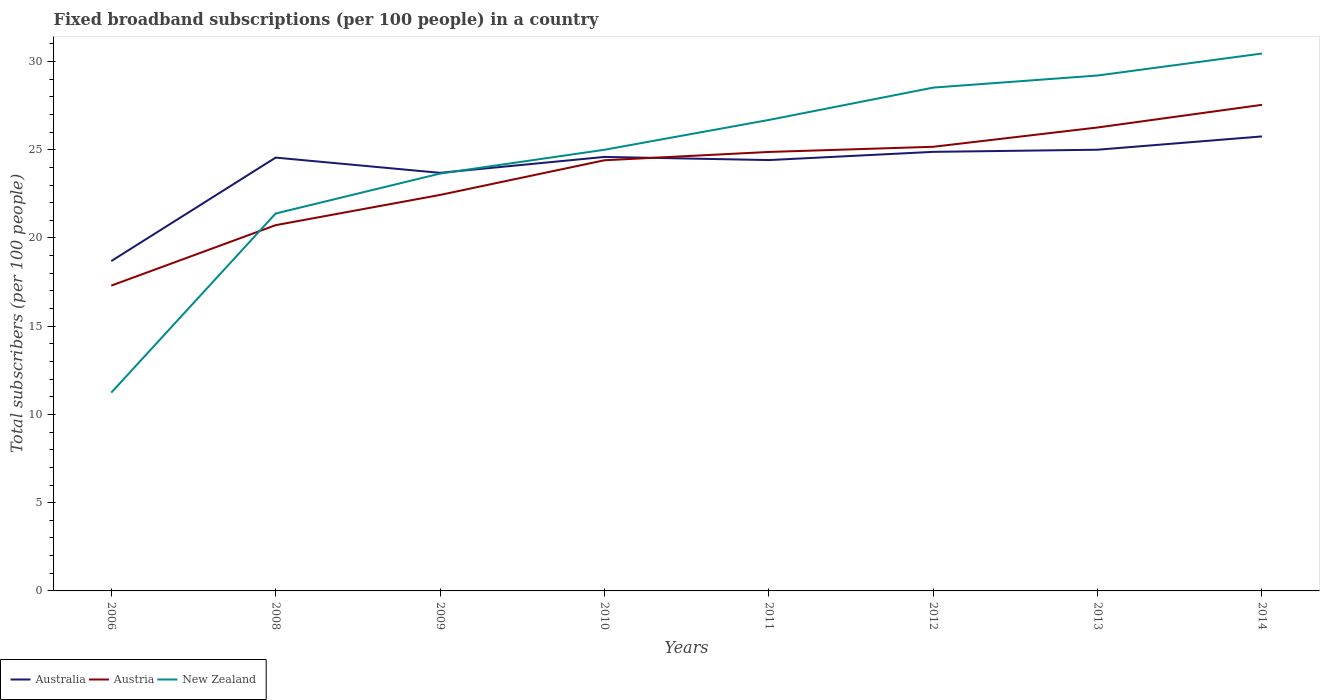How many different coloured lines are there?
Your answer should be compact. 3. Across all years, what is the maximum number of broadband subscriptions in New Zealand?
Provide a short and direct response. 11.24. In which year was the number of broadband subscriptions in Australia maximum?
Your answer should be compact. 2006. What is the total number of broadband subscriptions in Australia in the graph?
Offer a very short reply. -0.04. What is the difference between the highest and the second highest number of broadband subscriptions in New Zealand?
Offer a very short reply. 19.22. What is the difference between the highest and the lowest number of broadband subscriptions in Australia?
Give a very brief answer. 6. Are the values on the major ticks of Y-axis written in scientific E-notation?
Offer a very short reply. No. Does the graph contain any zero values?
Make the answer very short. No. Does the graph contain grids?
Keep it short and to the point. No. Where does the legend appear in the graph?
Ensure brevity in your answer.  Bottom left. How many legend labels are there?
Provide a succinct answer. 3. What is the title of the graph?
Offer a very short reply. Fixed broadband subscriptions (per 100 people) in a country. Does "Aruba" appear as one of the legend labels in the graph?
Ensure brevity in your answer.  No. What is the label or title of the Y-axis?
Give a very brief answer. Total subscribers (per 100 people). What is the Total subscribers (per 100 people) of Australia in 2006?
Provide a succinct answer. 18.69. What is the Total subscribers (per 100 people) of Austria in 2006?
Your answer should be compact. 17.3. What is the Total subscribers (per 100 people) in New Zealand in 2006?
Give a very brief answer. 11.24. What is the Total subscribers (per 100 people) of Australia in 2008?
Your answer should be very brief. 24.56. What is the Total subscribers (per 100 people) of Austria in 2008?
Offer a very short reply. 20.73. What is the Total subscribers (per 100 people) of New Zealand in 2008?
Provide a succinct answer. 21.39. What is the Total subscribers (per 100 people) of Australia in 2009?
Keep it short and to the point. 23.69. What is the Total subscribers (per 100 people) in Austria in 2009?
Your response must be concise. 22.44. What is the Total subscribers (per 100 people) of New Zealand in 2009?
Provide a succinct answer. 23.65. What is the Total subscribers (per 100 people) in Australia in 2010?
Keep it short and to the point. 24.59. What is the Total subscribers (per 100 people) of Austria in 2010?
Make the answer very short. 24.4. What is the Total subscribers (per 100 people) in New Zealand in 2010?
Your answer should be compact. 25. What is the Total subscribers (per 100 people) of Australia in 2011?
Your response must be concise. 24.41. What is the Total subscribers (per 100 people) of Austria in 2011?
Your answer should be very brief. 24.88. What is the Total subscribers (per 100 people) of New Zealand in 2011?
Offer a very short reply. 26.69. What is the Total subscribers (per 100 people) in Australia in 2012?
Offer a very short reply. 24.88. What is the Total subscribers (per 100 people) in Austria in 2012?
Keep it short and to the point. 25.17. What is the Total subscribers (per 100 people) in New Zealand in 2012?
Your response must be concise. 28.52. What is the Total subscribers (per 100 people) in Australia in 2013?
Ensure brevity in your answer.  25. What is the Total subscribers (per 100 people) in Austria in 2013?
Your answer should be compact. 26.26. What is the Total subscribers (per 100 people) of New Zealand in 2013?
Keep it short and to the point. 29.21. What is the Total subscribers (per 100 people) of Australia in 2014?
Ensure brevity in your answer.  25.76. What is the Total subscribers (per 100 people) of Austria in 2014?
Give a very brief answer. 27.54. What is the Total subscribers (per 100 people) in New Zealand in 2014?
Your answer should be compact. 30.45. Across all years, what is the maximum Total subscribers (per 100 people) of Australia?
Ensure brevity in your answer.  25.76. Across all years, what is the maximum Total subscribers (per 100 people) of Austria?
Your response must be concise. 27.54. Across all years, what is the maximum Total subscribers (per 100 people) in New Zealand?
Provide a short and direct response. 30.45. Across all years, what is the minimum Total subscribers (per 100 people) in Australia?
Ensure brevity in your answer.  18.69. Across all years, what is the minimum Total subscribers (per 100 people) of Austria?
Keep it short and to the point. 17.3. Across all years, what is the minimum Total subscribers (per 100 people) in New Zealand?
Provide a succinct answer. 11.24. What is the total Total subscribers (per 100 people) of Australia in the graph?
Offer a very short reply. 191.58. What is the total Total subscribers (per 100 people) in Austria in the graph?
Your response must be concise. 188.72. What is the total Total subscribers (per 100 people) of New Zealand in the graph?
Your answer should be very brief. 196.14. What is the difference between the Total subscribers (per 100 people) of Australia in 2006 and that in 2008?
Provide a short and direct response. -5.86. What is the difference between the Total subscribers (per 100 people) of Austria in 2006 and that in 2008?
Ensure brevity in your answer.  -3.43. What is the difference between the Total subscribers (per 100 people) in New Zealand in 2006 and that in 2008?
Offer a terse response. -10.15. What is the difference between the Total subscribers (per 100 people) of Australia in 2006 and that in 2009?
Give a very brief answer. -5. What is the difference between the Total subscribers (per 100 people) in Austria in 2006 and that in 2009?
Your response must be concise. -5.14. What is the difference between the Total subscribers (per 100 people) in New Zealand in 2006 and that in 2009?
Your answer should be compact. -12.41. What is the difference between the Total subscribers (per 100 people) in Australia in 2006 and that in 2010?
Provide a succinct answer. -5.9. What is the difference between the Total subscribers (per 100 people) in Austria in 2006 and that in 2010?
Give a very brief answer. -7.1. What is the difference between the Total subscribers (per 100 people) in New Zealand in 2006 and that in 2010?
Ensure brevity in your answer.  -13.76. What is the difference between the Total subscribers (per 100 people) of Australia in 2006 and that in 2011?
Your response must be concise. -5.72. What is the difference between the Total subscribers (per 100 people) of Austria in 2006 and that in 2011?
Provide a succinct answer. -7.58. What is the difference between the Total subscribers (per 100 people) of New Zealand in 2006 and that in 2011?
Offer a terse response. -15.45. What is the difference between the Total subscribers (per 100 people) of Australia in 2006 and that in 2012?
Keep it short and to the point. -6.19. What is the difference between the Total subscribers (per 100 people) in Austria in 2006 and that in 2012?
Give a very brief answer. -7.87. What is the difference between the Total subscribers (per 100 people) in New Zealand in 2006 and that in 2012?
Offer a terse response. -17.29. What is the difference between the Total subscribers (per 100 people) of Australia in 2006 and that in 2013?
Offer a very short reply. -6.31. What is the difference between the Total subscribers (per 100 people) of Austria in 2006 and that in 2013?
Ensure brevity in your answer.  -8.96. What is the difference between the Total subscribers (per 100 people) of New Zealand in 2006 and that in 2013?
Offer a terse response. -17.97. What is the difference between the Total subscribers (per 100 people) of Australia in 2006 and that in 2014?
Give a very brief answer. -7.06. What is the difference between the Total subscribers (per 100 people) of Austria in 2006 and that in 2014?
Provide a succinct answer. -10.24. What is the difference between the Total subscribers (per 100 people) of New Zealand in 2006 and that in 2014?
Your answer should be very brief. -19.22. What is the difference between the Total subscribers (per 100 people) of Australia in 2008 and that in 2009?
Provide a succinct answer. 0.86. What is the difference between the Total subscribers (per 100 people) of Austria in 2008 and that in 2009?
Provide a short and direct response. -1.71. What is the difference between the Total subscribers (per 100 people) of New Zealand in 2008 and that in 2009?
Ensure brevity in your answer.  -2.26. What is the difference between the Total subscribers (per 100 people) of Australia in 2008 and that in 2010?
Your response must be concise. -0.04. What is the difference between the Total subscribers (per 100 people) in Austria in 2008 and that in 2010?
Your answer should be compact. -3.68. What is the difference between the Total subscribers (per 100 people) of New Zealand in 2008 and that in 2010?
Your answer should be very brief. -3.61. What is the difference between the Total subscribers (per 100 people) of Australia in 2008 and that in 2011?
Your answer should be compact. 0.14. What is the difference between the Total subscribers (per 100 people) of Austria in 2008 and that in 2011?
Provide a short and direct response. -4.15. What is the difference between the Total subscribers (per 100 people) in New Zealand in 2008 and that in 2011?
Ensure brevity in your answer.  -5.3. What is the difference between the Total subscribers (per 100 people) of Australia in 2008 and that in 2012?
Your answer should be compact. -0.33. What is the difference between the Total subscribers (per 100 people) in Austria in 2008 and that in 2012?
Offer a terse response. -4.44. What is the difference between the Total subscribers (per 100 people) of New Zealand in 2008 and that in 2012?
Ensure brevity in your answer.  -7.13. What is the difference between the Total subscribers (per 100 people) of Australia in 2008 and that in 2013?
Give a very brief answer. -0.45. What is the difference between the Total subscribers (per 100 people) in Austria in 2008 and that in 2013?
Provide a short and direct response. -5.54. What is the difference between the Total subscribers (per 100 people) in New Zealand in 2008 and that in 2013?
Make the answer very short. -7.82. What is the difference between the Total subscribers (per 100 people) of Austria in 2008 and that in 2014?
Your answer should be very brief. -6.82. What is the difference between the Total subscribers (per 100 people) in New Zealand in 2008 and that in 2014?
Keep it short and to the point. -9.07. What is the difference between the Total subscribers (per 100 people) in Australia in 2009 and that in 2010?
Your answer should be compact. -0.9. What is the difference between the Total subscribers (per 100 people) in Austria in 2009 and that in 2010?
Your answer should be compact. -1.97. What is the difference between the Total subscribers (per 100 people) in New Zealand in 2009 and that in 2010?
Provide a short and direct response. -1.35. What is the difference between the Total subscribers (per 100 people) in Australia in 2009 and that in 2011?
Give a very brief answer. -0.72. What is the difference between the Total subscribers (per 100 people) of Austria in 2009 and that in 2011?
Keep it short and to the point. -2.44. What is the difference between the Total subscribers (per 100 people) of New Zealand in 2009 and that in 2011?
Your answer should be very brief. -3.04. What is the difference between the Total subscribers (per 100 people) in Australia in 2009 and that in 2012?
Keep it short and to the point. -1.19. What is the difference between the Total subscribers (per 100 people) of Austria in 2009 and that in 2012?
Ensure brevity in your answer.  -2.73. What is the difference between the Total subscribers (per 100 people) in New Zealand in 2009 and that in 2012?
Ensure brevity in your answer.  -4.87. What is the difference between the Total subscribers (per 100 people) in Australia in 2009 and that in 2013?
Make the answer very short. -1.31. What is the difference between the Total subscribers (per 100 people) of Austria in 2009 and that in 2013?
Make the answer very short. -3.82. What is the difference between the Total subscribers (per 100 people) of New Zealand in 2009 and that in 2013?
Your answer should be very brief. -5.56. What is the difference between the Total subscribers (per 100 people) in Australia in 2009 and that in 2014?
Your answer should be very brief. -2.06. What is the difference between the Total subscribers (per 100 people) of Austria in 2009 and that in 2014?
Your response must be concise. -5.11. What is the difference between the Total subscribers (per 100 people) of New Zealand in 2009 and that in 2014?
Provide a short and direct response. -6.8. What is the difference between the Total subscribers (per 100 people) of Australia in 2010 and that in 2011?
Provide a short and direct response. 0.18. What is the difference between the Total subscribers (per 100 people) of Austria in 2010 and that in 2011?
Provide a short and direct response. -0.47. What is the difference between the Total subscribers (per 100 people) in New Zealand in 2010 and that in 2011?
Give a very brief answer. -1.69. What is the difference between the Total subscribers (per 100 people) in Australia in 2010 and that in 2012?
Give a very brief answer. -0.29. What is the difference between the Total subscribers (per 100 people) in Austria in 2010 and that in 2012?
Ensure brevity in your answer.  -0.76. What is the difference between the Total subscribers (per 100 people) of New Zealand in 2010 and that in 2012?
Ensure brevity in your answer.  -3.52. What is the difference between the Total subscribers (per 100 people) in Australia in 2010 and that in 2013?
Keep it short and to the point. -0.41. What is the difference between the Total subscribers (per 100 people) in Austria in 2010 and that in 2013?
Your answer should be very brief. -1.86. What is the difference between the Total subscribers (per 100 people) in New Zealand in 2010 and that in 2013?
Ensure brevity in your answer.  -4.21. What is the difference between the Total subscribers (per 100 people) of Australia in 2010 and that in 2014?
Keep it short and to the point. -1.16. What is the difference between the Total subscribers (per 100 people) of Austria in 2010 and that in 2014?
Your answer should be compact. -3.14. What is the difference between the Total subscribers (per 100 people) in New Zealand in 2010 and that in 2014?
Offer a very short reply. -5.45. What is the difference between the Total subscribers (per 100 people) of Australia in 2011 and that in 2012?
Ensure brevity in your answer.  -0.47. What is the difference between the Total subscribers (per 100 people) of Austria in 2011 and that in 2012?
Make the answer very short. -0.29. What is the difference between the Total subscribers (per 100 people) in New Zealand in 2011 and that in 2012?
Your response must be concise. -1.83. What is the difference between the Total subscribers (per 100 people) in Australia in 2011 and that in 2013?
Your answer should be compact. -0.59. What is the difference between the Total subscribers (per 100 people) of Austria in 2011 and that in 2013?
Keep it short and to the point. -1.39. What is the difference between the Total subscribers (per 100 people) of New Zealand in 2011 and that in 2013?
Make the answer very short. -2.52. What is the difference between the Total subscribers (per 100 people) in Australia in 2011 and that in 2014?
Make the answer very short. -1.34. What is the difference between the Total subscribers (per 100 people) of Austria in 2011 and that in 2014?
Give a very brief answer. -2.67. What is the difference between the Total subscribers (per 100 people) of New Zealand in 2011 and that in 2014?
Your answer should be very brief. -3.76. What is the difference between the Total subscribers (per 100 people) in Australia in 2012 and that in 2013?
Give a very brief answer. -0.12. What is the difference between the Total subscribers (per 100 people) of Austria in 2012 and that in 2013?
Ensure brevity in your answer.  -1.09. What is the difference between the Total subscribers (per 100 people) of New Zealand in 2012 and that in 2013?
Offer a very short reply. -0.69. What is the difference between the Total subscribers (per 100 people) of Australia in 2012 and that in 2014?
Your answer should be compact. -0.88. What is the difference between the Total subscribers (per 100 people) of Austria in 2012 and that in 2014?
Make the answer very short. -2.38. What is the difference between the Total subscribers (per 100 people) in New Zealand in 2012 and that in 2014?
Offer a terse response. -1.93. What is the difference between the Total subscribers (per 100 people) in Australia in 2013 and that in 2014?
Offer a terse response. -0.75. What is the difference between the Total subscribers (per 100 people) in Austria in 2013 and that in 2014?
Make the answer very short. -1.28. What is the difference between the Total subscribers (per 100 people) in New Zealand in 2013 and that in 2014?
Give a very brief answer. -1.25. What is the difference between the Total subscribers (per 100 people) in Australia in 2006 and the Total subscribers (per 100 people) in Austria in 2008?
Ensure brevity in your answer.  -2.04. What is the difference between the Total subscribers (per 100 people) in Australia in 2006 and the Total subscribers (per 100 people) in New Zealand in 2008?
Ensure brevity in your answer.  -2.7. What is the difference between the Total subscribers (per 100 people) in Austria in 2006 and the Total subscribers (per 100 people) in New Zealand in 2008?
Your answer should be very brief. -4.09. What is the difference between the Total subscribers (per 100 people) of Australia in 2006 and the Total subscribers (per 100 people) of Austria in 2009?
Your response must be concise. -3.75. What is the difference between the Total subscribers (per 100 people) of Australia in 2006 and the Total subscribers (per 100 people) of New Zealand in 2009?
Ensure brevity in your answer.  -4.96. What is the difference between the Total subscribers (per 100 people) in Austria in 2006 and the Total subscribers (per 100 people) in New Zealand in 2009?
Keep it short and to the point. -6.35. What is the difference between the Total subscribers (per 100 people) in Australia in 2006 and the Total subscribers (per 100 people) in Austria in 2010?
Offer a very short reply. -5.71. What is the difference between the Total subscribers (per 100 people) of Australia in 2006 and the Total subscribers (per 100 people) of New Zealand in 2010?
Offer a very short reply. -6.31. What is the difference between the Total subscribers (per 100 people) in Austria in 2006 and the Total subscribers (per 100 people) in New Zealand in 2010?
Offer a terse response. -7.7. What is the difference between the Total subscribers (per 100 people) of Australia in 2006 and the Total subscribers (per 100 people) of Austria in 2011?
Keep it short and to the point. -6.18. What is the difference between the Total subscribers (per 100 people) of Australia in 2006 and the Total subscribers (per 100 people) of New Zealand in 2011?
Your answer should be compact. -8. What is the difference between the Total subscribers (per 100 people) in Austria in 2006 and the Total subscribers (per 100 people) in New Zealand in 2011?
Keep it short and to the point. -9.39. What is the difference between the Total subscribers (per 100 people) in Australia in 2006 and the Total subscribers (per 100 people) in Austria in 2012?
Keep it short and to the point. -6.48. What is the difference between the Total subscribers (per 100 people) in Australia in 2006 and the Total subscribers (per 100 people) in New Zealand in 2012?
Your answer should be compact. -9.83. What is the difference between the Total subscribers (per 100 people) in Austria in 2006 and the Total subscribers (per 100 people) in New Zealand in 2012?
Your answer should be very brief. -11.22. What is the difference between the Total subscribers (per 100 people) of Australia in 2006 and the Total subscribers (per 100 people) of Austria in 2013?
Make the answer very short. -7.57. What is the difference between the Total subscribers (per 100 people) of Australia in 2006 and the Total subscribers (per 100 people) of New Zealand in 2013?
Provide a short and direct response. -10.52. What is the difference between the Total subscribers (per 100 people) in Austria in 2006 and the Total subscribers (per 100 people) in New Zealand in 2013?
Keep it short and to the point. -11.91. What is the difference between the Total subscribers (per 100 people) of Australia in 2006 and the Total subscribers (per 100 people) of Austria in 2014?
Your answer should be very brief. -8.85. What is the difference between the Total subscribers (per 100 people) of Australia in 2006 and the Total subscribers (per 100 people) of New Zealand in 2014?
Your answer should be compact. -11.76. What is the difference between the Total subscribers (per 100 people) in Austria in 2006 and the Total subscribers (per 100 people) in New Zealand in 2014?
Offer a terse response. -13.15. What is the difference between the Total subscribers (per 100 people) of Australia in 2008 and the Total subscribers (per 100 people) of Austria in 2009?
Your answer should be compact. 2.12. What is the difference between the Total subscribers (per 100 people) in Australia in 2008 and the Total subscribers (per 100 people) in New Zealand in 2009?
Offer a very short reply. 0.91. What is the difference between the Total subscribers (per 100 people) of Austria in 2008 and the Total subscribers (per 100 people) of New Zealand in 2009?
Give a very brief answer. -2.92. What is the difference between the Total subscribers (per 100 people) in Australia in 2008 and the Total subscribers (per 100 people) in Austria in 2010?
Your response must be concise. 0.15. What is the difference between the Total subscribers (per 100 people) in Australia in 2008 and the Total subscribers (per 100 people) in New Zealand in 2010?
Offer a very short reply. -0.44. What is the difference between the Total subscribers (per 100 people) of Austria in 2008 and the Total subscribers (per 100 people) of New Zealand in 2010?
Provide a short and direct response. -4.27. What is the difference between the Total subscribers (per 100 people) of Australia in 2008 and the Total subscribers (per 100 people) of Austria in 2011?
Your answer should be very brief. -0.32. What is the difference between the Total subscribers (per 100 people) of Australia in 2008 and the Total subscribers (per 100 people) of New Zealand in 2011?
Give a very brief answer. -2.13. What is the difference between the Total subscribers (per 100 people) in Austria in 2008 and the Total subscribers (per 100 people) in New Zealand in 2011?
Offer a terse response. -5.96. What is the difference between the Total subscribers (per 100 people) in Australia in 2008 and the Total subscribers (per 100 people) in Austria in 2012?
Provide a succinct answer. -0.61. What is the difference between the Total subscribers (per 100 people) in Australia in 2008 and the Total subscribers (per 100 people) in New Zealand in 2012?
Provide a succinct answer. -3.97. What is the difference between the Total subscribers (per 100 people) in Austria in 2008 and the Total subscribers (per 100 people) in New Zealand in 2012?
Make the answer very short. -7.79. What is the difference between the Total subscribers (per 100 people) of Australia in 2008 and the Total subscribers (per 100 people) of Austria in 2013?
Your response must be concise. -1.71. What is the difference between the Total subscribers (per 100 people) in Australia in 2008 and the Total subscribers (per 100 people) in New Zealand in 2013?
Offer a very short reply. -4.65. What is the difference between the Total subscribers (per 100 people) in Austria in 2008 and the Total subscribers (per 100 people) in New Zealand in 2013?
Offer a very short reply. -8.48. What is the difference between the Total subscribers (per 100 people) in Australia in 2008 and the Total subscribers (per 100 people) in Austria in 2014?
Your answer should be compact. -2.99. What is the difference between the Total subscribers (per 100 people) of Australia in 2008 and the Total subscribers (per 100 people) of New Zealand in 2014?
Ensure brevity in your answer.  -5.9. What is the difference between the Total subscribers (per 100 people) of Austria in 2008 and the Total subscribers (per 100 people) of New Zealand in 2014?
Your response must be concise. -9.73. What is the difference between the Total subscribers (per 100 people) in Australia in 2009 and the Total subscribers (per 100 people) in Austria in 2010?
Give a very brief answer. -0.71. What is the difference between the Total subscribers (per 100 people) of Australia in 2009 and the Total subscribers (per 100 people) of New Zealand in 2010?
Keep it short and to the point. -1.31. What is the difference between the Total subscribers (per 100 people) of Austria in 2009 and the Total subscribers (per 100 people) of New Zealand in 2010?
Provide a succinct answer. -2.56. What is the difference between the Total subscribers (per 100 people) of Australia in 2009 and the Total subscribers (per 100 people) of Austria in 2011?
Your answer should be very brief. -1.18. What is the difference between the Total subscribers (per 100 people) of Australia in 2009 and the Total subscribers (per 100 people) of New Zealand in 2011?
Give a very brief answer. -3. What is the difference between the Total subscribers (per 100 people) in Austria in 2009 and the Total subscribers (per 100 people) in New Zealand in 2011?
Ensure brevity in your answer.  -4.25. What is the difference between the Total subscribers (per 100 people) in Australia in 2009 and the Total subscribers (per 100 people) in Austria in 2012?
Keep it short and to the point. -1.48. What is the difference between the Total subscribers (per 100 people) of Australia in 2009 and the Total subscribers (per 100 people) of New Zealand in 2012?
Make the answer very short. -4.83. What is the difference between the Total subscribers (per 100 people) of Austria in 2009 and the Total subscribers (per 100 people) of New Zealand in 2012?
Offer a terse response. -6.08. What is the difference between the Total subscribers (per 100 people) of Australia in 2009 and the Total subscribers (per 100 people) of Austria in 2013?
Provide a short and direct response. -2.57. What is the difference between the Total subscribers (per 100 people) of Australia in 2009 and the Total subscribers (per 100 people) of New Zealand in 2013?
Give a very brief answer. -5.52. What is the difference between the Total subscribers (per 100 people) in Austria in 2009 and the Total subscribers (per 100 people) in New Zealand in 2013?
Your response must be concise. -6.77. What is the difference between the Total subscribers (per 100 people) in Australia in 2009 and the Total subscribers (per 100 people) in Austria in 2014?
Offer a very short reply. -3.85. What is the difference between the Total subscribers (per 100 people) in Australia in 2009 and the Total subscribers (per 100 people) in New Zealand in 2014?
Offer a terse response. -6.76. What is the difference between the Total subscribers (per 100 people) in Austria in 2009 and the Total subscribers (per 100 people) in New Zealand in 2014?
Provide a succinct answer. -8.01. What is the difference between the Total subscribers (per 100 people) of Australia in 2010 and the Total subscribers (per 100 people) of Austria in 2011?
Make the answer very short. -0.28. What is the difference between the Total subscribers (per 100 people) of Australia in 2010 and the Total subscribers (per 100 people) of New Zealand in 2011?
Make the answer very short. -2.1. What is the difference between the Total subscribers (per 100 people) of Austria in 2010 and the Total subscribers (per 100 people) of New Zealand in 2011?
Keep it short and to the point. -2.28. What is the difference between the Total subscribers (per 100 people) of Australia in 2010 and the Total subscribers (per 100 people) of Austria in 2012?
Offer a terse response. -0.57. What is the difference between the Total subscribers (per 100 people) in Australia in 2010 and the Total subscribers (per 100 people) in New Zealand in 2012?
Provide a short and direct response. -3.93. What is the difference between the Total subscribers (per 100 people) of Austria in 2010 and the Total subscribers (per 100 people) of New Zealand in 2012?
Provide a succinct answer. -4.12. What is the difference between the Total subscribers (per 100 people) of Australia in 2010 and the Total subscribers (per 100 people) of Austria in 2013?
Keep it short and to the point. -1.67. What is the difference between the Total subscribers (per 100 people) in Australia in 2010 and the Total subscribers (per 100 people) in New Zealand in 2013?
Your response must be concise. -4.61. What is the difference between the Total subscribers (per 100 people) in Austria in 2010 and the Total subscribers (per 100 people) in New Zealand in 2013?
Your answer should be very brief. -4.8. What is the difference between the Total subscribers (per 100 people) of Australia in 2010 and the Total subscribers (per 100 people) of Austria in 2014?
Provide a short and direct response. -2.95. What is the difference between the Total subscribers (per 100 people) of Australia in 2010 and the Total subscribers (per 100 people) of New Zealand in 2014?
Provide a succinct answer. -5.86. What is the difference between the Total subscribers (per 100 people) in Austria in 2010 and the Total subscribers (per 100 people) in New Zealand in 2014?
Make the answer very short. -6.05. What is the difference between the Total subscribers (per 100 people) of Australia in 2011 and the Total subscribers (per 100 people) of Austria in 2012?
Provide a succinct answer. -0.75. What is the difference between the Total subscribers (per 100 people) in Australia in 2011 and the Total subscribers (per 100 people) in New Zealand in 2012?
Provide a succinct answer. -4.11. What is the difference between the Total subscribers (per 100 people) of Austria in 2011 and the Total subscribers (per 100 people) of New Zealand in 2012?
Your answer should be compact. -3.65. What is the difference between the Total subscribers (per 100 people) of Australia in 2011 and the Total subscribers (per 100 people) of Austria in 2013?
Ensure brevity in your answer.  -1.85. What is the difference between the Total subscribers (per 100 people) of Australia in 2011 and the Total subscribers (per 100 people) of New Zealand in 2013?
Make the answer very short. -4.79. What is the difference between the Total subscribers (per 100 people) in Austria in 2011 and the Total subscribers (per 100 people) in New Zealand in 2013?
Offer a terse response. -4.33. What is the difference between the Total subscribers (per 100 people) in Australia in 2011 and the Total subscribers (per 100 people) in Austria in 2014?
Provide a short and direct response. -3.13. What is the difference between the Total subscribers (per 100 people) of Australia in 2011 and the Total subscribers (per 100 people) of New Zealand in 2014?
Offer a terse response. -6.04. What is the difference between the Total subscribers (per 100 people) in Austria in 2011 and the Total subscribers (per 100 people) in New Zealand in 2014?
Offer a terse response. -5.58. What is the difference between the Total subscribers (per 100 people) of Australia in 2012 and the Total subscribers (per 100 people) of Austria in 2013?
Provide a short and direct response. -1.38. What is the difference between the Total subscribers (per 100 people) of Australia in 2012 and the Total subscribers (per 100 people) of New Zealand in 2013?
Your response must be concise. -4.33. What is the difference between the Total subscribers (per 100 people) of Austria in 2012 and the Total subscribers (per 100 people) of New Zealand in 2013?
Offer a terse response. -4.04. What is the difference between the Total subscribers (per 100 people) in Australia in 2012 and the Total subscribers (per 100 people) in Austria in 2014?
Provide a short and direct response. -2.66. What is the difference between the Total subscribers (per 100 people) in Australia in 2012 and the Total subscribers (per 100 people) in New Zealand in 2014?
Provide a succinct answer. -5.57. What is the difference between the Total subscribers (per 100 people) in Austria in 2012 and the Total subscribers (per 100 people) in New Zealand in 2014?
Provide a short and direct response. -5.28. What is the difference between the Total subscribers (per 100 people) in Australia in 2013 and the Total subscribers (per 100 people) in Austria in 2014?
Keep it short and to the point. -2.54. What is the difference between the Total subscribers (per 100 people) of Australia in 2013 and the Total subscribers (per 100 people) of New Zealand in 2014?
Offer a very short reply. -5.45. What is the difference between the Total subscribers (per 100 people) in Austria in 2013 and the Total subscribers (per 100 people) in New Zealand in 2014?
Provide a short and direct response. -4.19. What is the average Total subscribers (per 100 people) in Australia per year?
Offer a very short reply. 23.95. What is the average Total subscribers (per 100 people) in Austria per year?
Keep it short and to the point. 23.59. What is the average Total subscribers (per 100 people) of New Zealand per year?
Keep it short and to the point. 24.52. In the year 2006, what is the difference between the Total subscribers (per 100 people) in Australia and Total subscribers (per 100 people) in Austria?
Your answer should be compact. 1.39. In the year 2006, what is the difference between the Total subscribers (per 100 people) of Australia and Total subscribers (per 100 people) of New Zealand?
Keep it short and to the point. 7.46. In the year 2006, what is the difference between the Total subscribers (per 100 people) of Austria and Total subscribers (per 100 people) of New Zealand?
Your answer should be compact. 6.06. In the year 2008, what is the difference between the Total subscribers (per 100 people) in Australia and Total subscribers (per 100 people) in Austria?
Offer a terse response. 3.83. In the year 2008, what is the difference between the Total subscribers (per 100 people) in Australia and Total subscribers (per 100 people) in New Zealand?
Your answer should be compact. 3.17. In the year 2008, what is the difference between the Total subscribers (per 100 people) of Austria and Total subscribers (per 100 people) of New Zealand?
Give a very brief answer. -0.66. In the year 2009, what is the difference between the Total subscribers (per 100 people) in Australia and Total subscribers (per 100 people) in Austria?
Your answer should be compact. 1.25. In the year 2009, what is the difference between the Total subscribers (per 100 people) in Australia and Total subscribers (per 100 people) in New Zealand?
Offer a terse response. 0.04. In the year 2009, what is the difference between the Total subscribers (per 100 people) in Austria and Total subscribers (per 100 people) in New Zealand?
Keep it short and to the point. -1.21. In the year 2010, what is the difference between the Total subscribers (per 100 people) of Australia and Total subscribers (per 100 people) of Austria?
Make the answer very short. 0.19. In the year 2010, what is the difference between the Total subscribers (per 100 people) of Australia and Total subscribers (per 100 people) of New Zealand?
Offer a terse response. -0.41. In the year 2010, what is the difference between the Total subscribers (per 100 people) of Austria and Total subscribers (per 100 people) of New Zealand?
Your answer should be very brief. -0.6. In the year 2011, what is the difference between the Total subscribers (per 100 people) in Australia and Total subscribers (per 100 people) in Austria?
Ensure brevity in your answer.  -0.46. In the year 2011, what is the difference between the Total subscribers (per 100 people) of Australia and Total subscribers (per 100 people) of New Zealand?
Your answer should be compact. -2.27. In the year 2011, what is the difference between the Total subscribers (per 100 people) in Austria and Total subscribers (per 100 people) in New Zealand?
Make the answer very short. -1.81. In the year 2012, what is the difference between the Total subscribers (per 100 people) of Australia and Total subscribers (per 100 people) of Austria?
Provide a succinct answer. -0.29. In the year 2012, what is the difference between the Total subscribers (per 100 people) of Australia and Total subscribers (per 100 people) of New Zealand?
Ensure brevity in your answer.  -3.64. In the year 2012, what is the difference between the Total subscribers (per 100 people) of Austria and Total subscribers (per 100 people) of New Zealand?
Provide a succinct answer. -3.35. In the year 2013, what is the difference between the Total subscribers (per 100 people) of Australia and Total subscribers (per 100 people) of Austria?
Offer a very short reply. -1.26. In the year 2013, what is the difference between the Total subscribers (per 100 people) of Australia and Total subscribers (per 100 people) of New Zealand?
Your answer should be very brief. -4.21. In the year 2013, what is the difference between the Total subscribers (per 100 people) in Austria and Total subscribers (per 100 people) in New Zealand?
Provide a short and direct response. -2.94. In the year 2014, what is the difference between the Total subscribers (per 100 people) in Australia and Total subscribers (per 100 people) in Austria?
Offer a terse response. -1.79. In the year 2014, what is the difference between the Total subscribers (per 100 people) of Australia and Total subscribers (per 100 people) of New Zealand?
Offer a very short reply. -4.7. In the year 2014, what is the difference between the Total subscribers (per 100 people) in Austria and Total subscribers (per 100 people) in New Zealand?
Offer a terse response. -2.91. What is the ratio of the Total subscribers (per 100 people) of Australia in 2006 to that in 2008?
Offer a very short reply. 0.76. What is the ratio of the Total subscribers (per 100 people) of Austria in 2006 to that in 2008?
Provide a short and direct response. 0.83. What is the ratio of the Total subscribers (per 100 people) of New Zealand in 2006 to that in 2008?
Your answer should be compact. 0.53. What is the ratio of the Total subscribers (per 100 people) in Australia in 2006 to that in 2009?
Ensure brevity in your answer.  0.79. What is the ratio of the Total subscribers (per 100 people) of Austria in 2006 to that in 2009?
Keep it short and to the point. 0.77. What is the ratio of the Total subscribers (per 100 people) of New Zealand in 2006 to that in 2009?
Provide a succinct answer. 0.48. What is the ratio of the Total subscribers (per 100 people) in Australia in 2006 to that in 2010?
Give a very brief answer. 0.76. What is the ratio of the Total subscribers (per 100 people) of Austria in 2006 to that in 2010?
Provide a succinct answer. 0.71. What is the ratio of the Total subscribers (per 100 people) of New Zealand in 2006 to that in 2010?
Give a very brief answer. 0.45. What is the ratio of the Total subscribers (per 100 people) in Australia in 2006 to that in 2011?
Your answer should be compact. 0.77. What is the ratio of the Total subscribers (per 100 people) in Austria in 2006 to that in 2011?
Ensure brevity in your answer.  0.7. What is the ratio of the Total subscribers (per 100 people) of New Zealand in 2006 to that in 2011?
Offer a terse response. 0.42. What is the ratio of the Total subscribers (per 100 people) of Australia in 2006 to that in 2012?
Your answer should be compact. 0.75. What is the ratio of the Total subscribers (per 100 people) in Austria in 2006 to that in 2012?
Provide a short and direct response. 0.69. What is the ratio of the Total subscribers (per 100 people) in New Zealand in 2006 to that in 2012?
Offer a very short reply. 0.39. What is the ratio of the Total subscribers (per 100 people) in Australia in 2006 to that in 2013?
Give a very brief answer. 0.75. What is the ratio of the Total subscribers (per 100 people) of Austria in 2006 to that in 2013?
Keep it short and to the point. 0.66. What is the ratio of the Total subscribers (per 100 people) of New Zealand in 2006 to that in 2013?
Give a very brief answer. 0.38. What is the ratio of the Total subscribers (per 100 people) of Australia in 2006 to that in 2014?
Provide a short and direct response. 0.73. What is the ratio of the Total subscribers (per 100 people) of Austria in 2006 to that in 2014?
Your answer should be compact. 0.63. What is the ratio of the Total subscribers (per 100 people) in New Zealand in 2006 to that in 2014?
Provide a succinct answer. 0.37. What is the ratio of the Total subscribers (per 100 people) of Australia in 2008 to that in 2009?
Offer a very short reply. 1.04. What is the ratio of the Total subscribers (per 100 people) in Austria in 2008 to that in 2009?
Provide a succinct answer. 0.92. What is the ratio of the Total subscribers (per 100 people) in New Zealand in 2008 to that in 2009?
Provide a short and direct response. 0.9. What is the ratio of the Total subscribers (per 100 people) in Austria in 2008 to that in 2010?
Your answer should be compact. 0.85. What is the ratio of the Total subscribers (per 100 people) of New Zealand in 2008 to that in 2010?
Keep it short and to the point. 0.86. What is the ratio of the Total subscribers (per 100 people) in Australia in 2008 to that in 2011?
Give a very brief answer. 1.01. What is the ratio of the Total subscribers (per 100 people) in Austria in 2008 to that in 2011?
Provide a short and direct response. 0.83. What is the ratio of the Total subscribers (per 100 people) in New Zealand in 2008 to that in 2011?
Ensure brevity in your answer.  0.8. What is the ratio of the Total subscribers (per 100 people) of Australia in 2008 to that in 2012?
Keep it short and to the point. 0.99. What is the ratio of the Total subscribers (per 100 people) in Austria in 2008 to that in 2012?
Your answer should be compact. 0.82. What is the ratio of the Total subscribers (per 100 people) in New Zealand in 2008 to that in 2012?
Offer a very short reply. 0.75. What is the ratio of the Total subscribers (per 100 people) of Australia in 2008 to that in 2013?
Keep it short and to the point. 0.98. What is the ratio of the Total subscribers (per 100 people) in Austria in 2008 to that in 2013?
Give a very brief answer. 0.79. What is the ratio of the Total subscribers (per 100 people) in New Zealand in 2008 to that in 2013?
Provide a short and direct response. 0.73. What is the ratio of the Total subscribers (per 100 people) of Australia in 2008 to that in 2014?
Keep it short and to the point. 0.95. What is the ratio of the Total subscribers (per 100 people) of Austria in 2008 to that in 2014?
Your response must be concise. 0.75. What is the ratio of the Total subscribers (per 100 people) of New Zealand in 2008 to that in 2014?
Provide a short and direct response. 0.7. What is the ratio of the Total subscribers (per 100 people) of Australia in 2009 to that in 2010?
Your answer should be very brief. 0.96. What is the ratio of the Total subscribers (per 100 people) of Austria in 2009 to that in 2010?
Provide a succinct answer. 0.92. What is the ratio of the Total subscribers (per 100 people) in New Zealand in 2009 to that in 2010?
Ensure brevity in your answer.  0.95. What is the ratio of the Total subscribers (per 100 people) in Australia in 2009 to that in 2011?
Give a very brief answer. 0.97. What is the ratio of the Total subscribers (per 100 people) of Austria in 2009 to that in 2011?
Provide a succinct answer. 0.9. What is the ratio of the Total subscribers (per 100 people) in New Zealand in 2009 to that in 2011?
Your answer should be compact. 0.89. What is the ratio of the Total subscribers (per 100 people) in Australia in 2009 to that in 2012?
Provide a succinct answer. 0.95. What is the ratio of the Total subscribers (per 100 people) in Austria in 2009 to that in 2012?
Your answer should be compact. 0.89. What is the ratio of the Total subscribers (per 100 people) of New Zealand in 2009 to that in 2012?
Keep it short and to the point. 0.83. What is the ratio of the Total subscribers (per 100 people) of Australia in 2009 to that in 2013?
Keep it short and to the point. 0.95. What is the ratio of the Total subscribers (per 100 people) in Austria in 2009 to that in 2013?
Give a very brief answer. 0.85. What is the ratio of the Total subscribers (per 100 people) in New Zealand in 2009 to that in 2013?
Keep it short and to the point. 0.81. What is the ratio of the Total subscribers (per 100 people) in Australia in 2009 to that in 2014?
Offer a very short reply. 0.92. What is the ratio of the Total subscribers (per 100 people) in Austria in 2009 to that in 2014?
Your answer should be compact. 0.81. What is the ratio of the Total subscribers (per 100 people) of New Zealand in 2009 to that in 2014?
Offer a very short reply. 0.78. What is the ratio of the Total subscribers (per 100 people) in Australia in 2010 to that in 2011?
Provide a succinct answer. 1.01. What is the ratio of the Total subscribers (per 100 people) of Austria in 2010 to that in 2011?
Provide a succinct answer. 0.98. What is the ratio of the Total subscribers (per 100 people) of New Zealand in 2010 to that in 2011?
Give a very brief answer. 0.94. What is the ratio of the Total subscribers (per 100 people) of Australia in 2010 to that in 2012?
Offer a terse response. 0.99. What is the ratio of the Total subscribers (per 100 people) in Austria in 2010 to that in 2012?
Offer a very short reply. 0.97. What is the ratio of the Total subscribers (per 100 people) of New Zealand in 2010 to that in 2012?
Offer a terse response. 0.88. What is the ratio of the Total subscribers (per 100 people) in Australia in 2010 to that in 2013?
Make the answer very short. 0.98. What is the ratio of the Total subscribers (per 100 people) in Austria in 2010 to that in 2013?
Offer a very short reply. 0.93. What is the ratio of the Total subscribers (per 100 people) of New Zealand in 2010 to that in 2013?
Offer a very short reply. 0.86. What is the ratio of the Total subscribers (per 100 people) of Australia in 2010 to that in 2014?
Provide a succinct answer. 0.95. What is the ratio of the Total subscribers (per 100 people) of Austria in 2010 to that in 2014?
Offer a terse response. 0.89. What is the ratio of the Total subscribers (per 100 people) in New Zealand in 2010 to that in 2014?
Your response must be concise. 0.82. What is the ratio of the Total subscribers (per 100 people) of Australia in 2011 to that in 2012?
Offer a terse response. 0.98. What is the ratio of the Total subscribers (per 100 people) in Austria in 2011 to that in 2012?
Make the answer very short. 0.99. What is the ratio of the Total subscribers (per 100 people) of New Zealand in 2011 to that in 2012?
Your response must be concise. 0.94. What is the ratio of the Total subscribers (per 100 people) in Australia in 2011 to that in 2013?
Offer a very short reply. 0.98. What is the ratio of the Total subscribers (per 100 people) in Austria in 2011 to that in 2013?
Offer a very short reply. 0.95. What is the ratio of the Total subscribers (per 100 people) in New Zealand in 2011 to that in 2013?
Keep it short and to the point. 0.91. What is the ratio of the Total subscribers (per 100 people) in Australia in 2011 to that in 2014?
Offer a very short reply. 0.95. What is the ratio of the Total subscribers (per 100 people) of Austria in 2011 to that in 2014?
Your response must be concise. 0.9. What is the ratio of the Total subscribers (per 100 people) in New Zealand in 2011 to that in 2014?
Provide a succinct answer. 0.88. What is the ratio of the Total subscribers (per 100 people) in Australia in 2012 to that in 2013?
Ensure brevity in your answer.  1. What is the ratio of the Total subscribers (per 100 people) of Austria in 2012 to that in 2013?
Offer a terse response. 0.96. What is the ratio of the Total subscribers (per 100 people) in New Zealand in 2012 to that in 2013?
Make the answer very short. 0.98. What is the ratio of the Total subscribers (per 100 people) in Austria in 2012 to that in 2014?
Ensure brevity in your answer.  0.91. What is the ratio of the Total subscribers (per 100 people) of New Zealand in 2012 to that in 2014?
Give a very brief answer. 0.94. What is the ratio of the Total subscribers (per 100 people) of Australia in 2013 to that in 2014?
Offer a terse response. 0.97. What is the ratio of the Total subscribers (per 100 people) of Austria in 2013 to that in 2014?
Offer a terse response. 0.95. What is the ratio of the Total subscribers (per 100 people) of New Zealand in 2013 to that in 2014?
Make the answer very short. 0.96. What is the difference between the highest and the second highest Total subscribers (per 100 people) in Australia?
Offer a terse response. 0.75. What is the difference between the highest and the second highest Total subscribers (per 100 people) in Austria?
Ensure brevity in your answer.  1.28. What is the difference between the highest and the second highest Total subscribers (per 100 people) of New Zealand?
Your answer should be compact. 1.25. What is the difference between the highest and the lowest Total subscribers (per 100 people) of Australia?
Provide a succinct answer. 7.06. What is the difference between the highest and the lowest Total subscribers (per 100 people) of Austria?
Offer a very short reply. 10.24. What is the difference between the highest and the lowest Total subscribers (per 100 people) in New Zealand?
Your answer should be very brief. 19.22. 